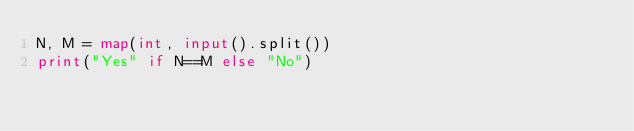<code> <loc_0><loc_0><loc_500><loc_500><_Python_>N, M = map(int, input().split())
print("Yes" if N==M else "No")</code> 